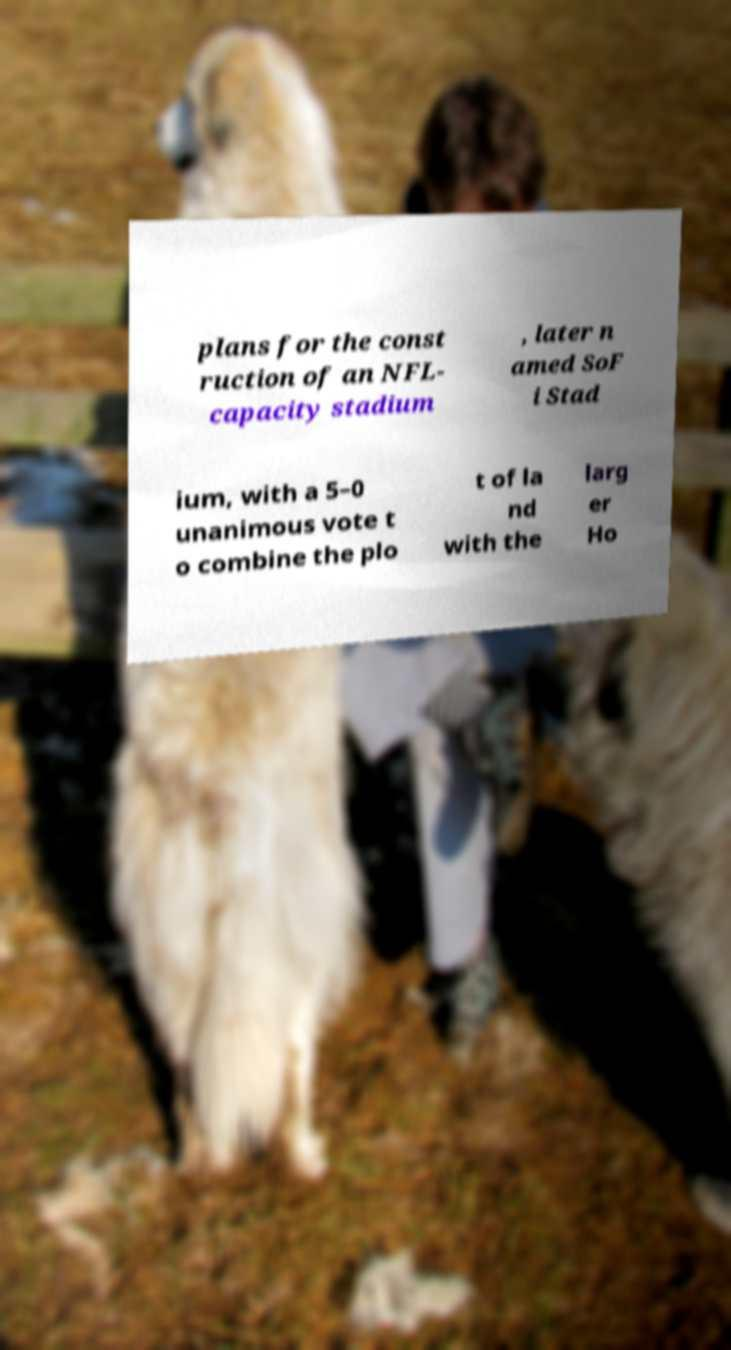I need the written content from this picture converted into text. Can you do that? plans for the const ruction of an NFL- capacity stadium , later n amed SoF i Stad ium, with a 5–0 unanimous vote t o combine the plo t of la nd with the larg er Ho 